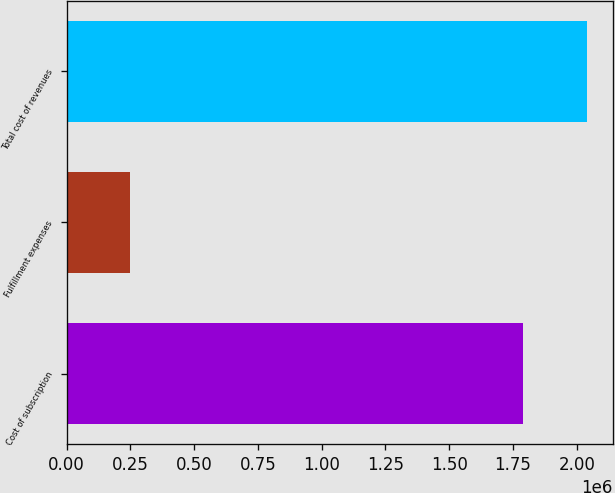Convert chart. <chart><loc_0><loc_0><loc_500><loc_500><bar_chart><fcel>Cost of subscription<fcel>Fulfillment expenses<fcel>Total cost of revenues<nl><fcel>1.7896e+06<fcel>250305<fcel>2.0399e+06<nl></chart> 